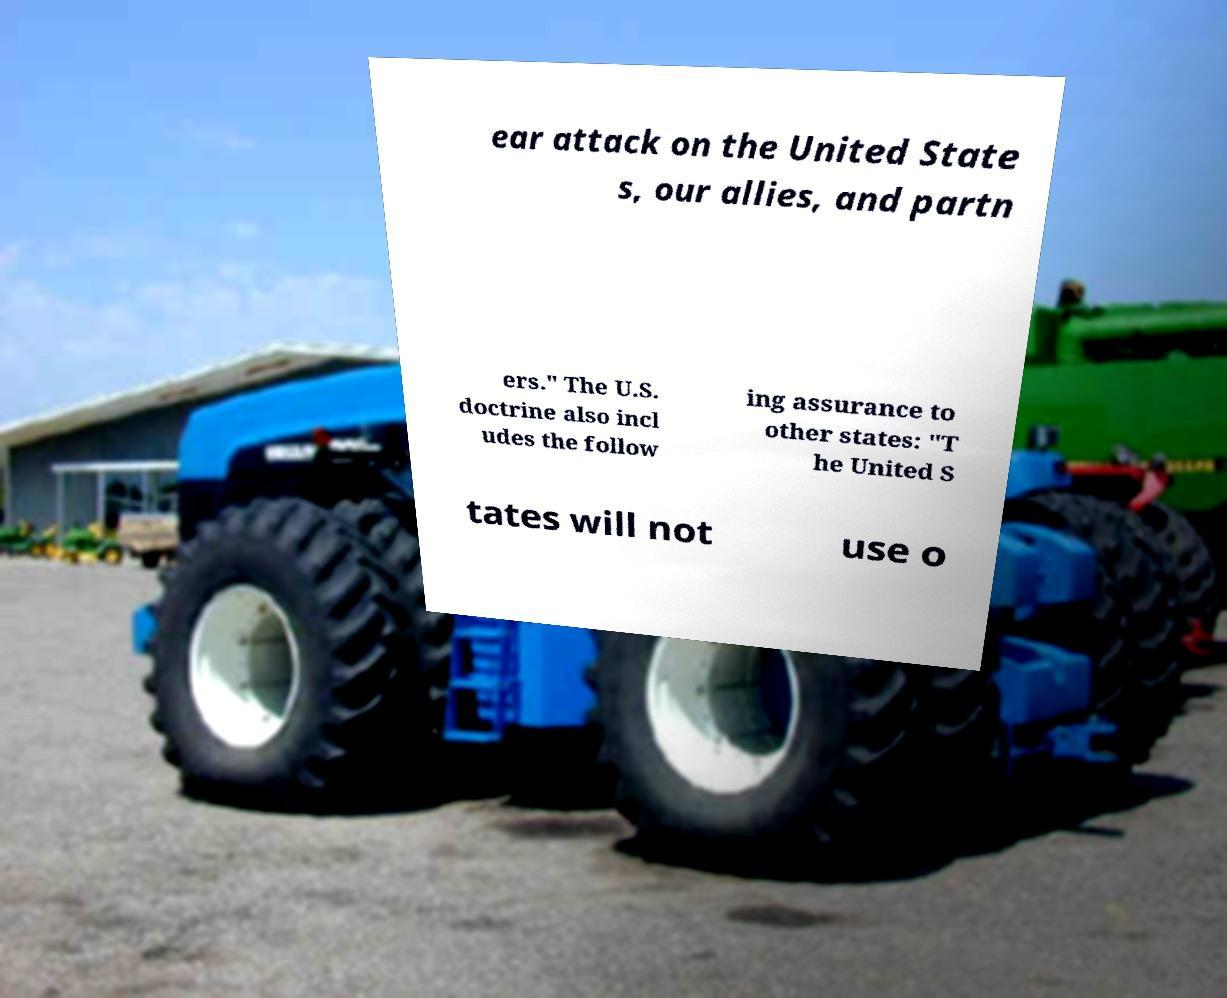I need the written content from this picture converted into text. Can you do that? ear attack on the United State s, our allies, and partn ers." The U.S. doctrine also incl udes the follow ing assurance to other states: "T he United S tates will not use o 